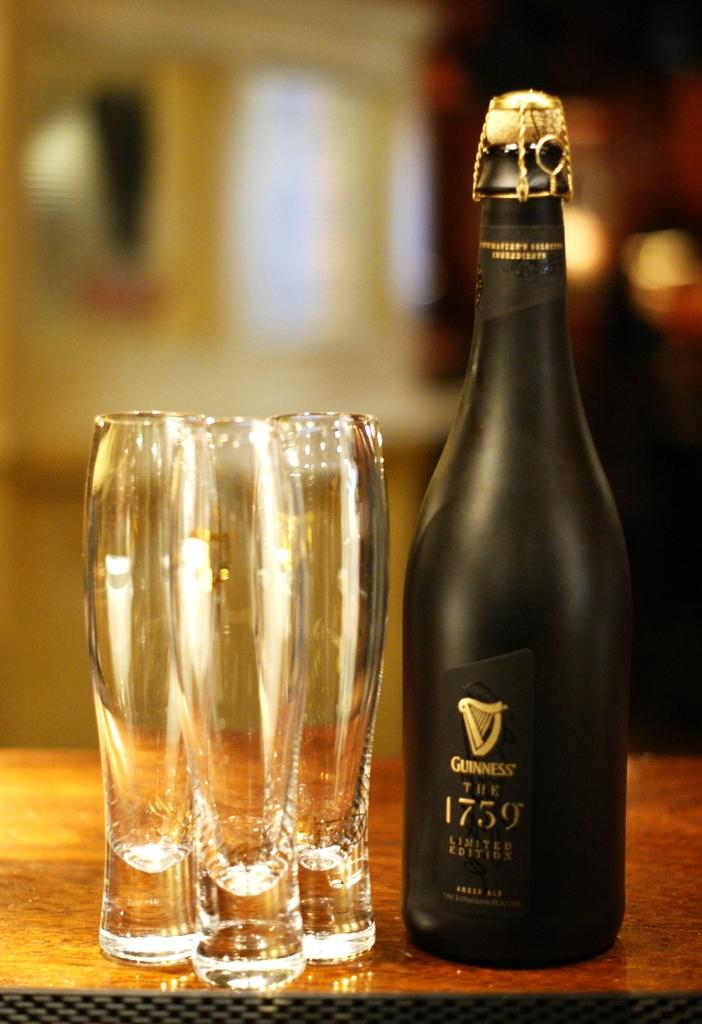Provide a one-sentence caption for the provided image. A black bottle with 1759 printed on the front next to three glasses. 